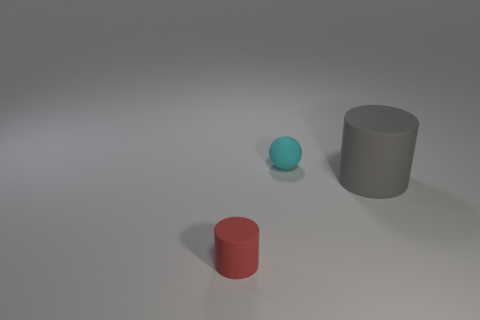Is there any other thing that is the same size as the gray object?
Provide a short and direct response. No. The object that is both in front of the tiny cyan rubber object and left of the large cylinder has what shape?
Your answer should be compact. Cylinder. What is the size of the matte cylinder that is behind the rubber object that is left of the cyan thing?
Your answer should be very brief. Large. How many other things are there of the same color as the tiny cylinder?
Offer a very short reply. 0. What material is the cyan sphere?
Your response must be concise. Rubber. Is there a small red object?
Your answer should be compact. Yes. Are there the same number of small red cylinders that are right of the small cyan sphere and blue metal cubes?
Provide a succinct answer. Yes. Are there any other things that are the same material as the big gray object?
Make the answer very short. Yes. What number of tiny objects are either gray metallic balls or cyan rubber things?
Provide a succinct answer. 1. Does the cylinder left of the gray matte thing have the same material as the tiny cyan sphere?
Give a very brief answer. Yes. 